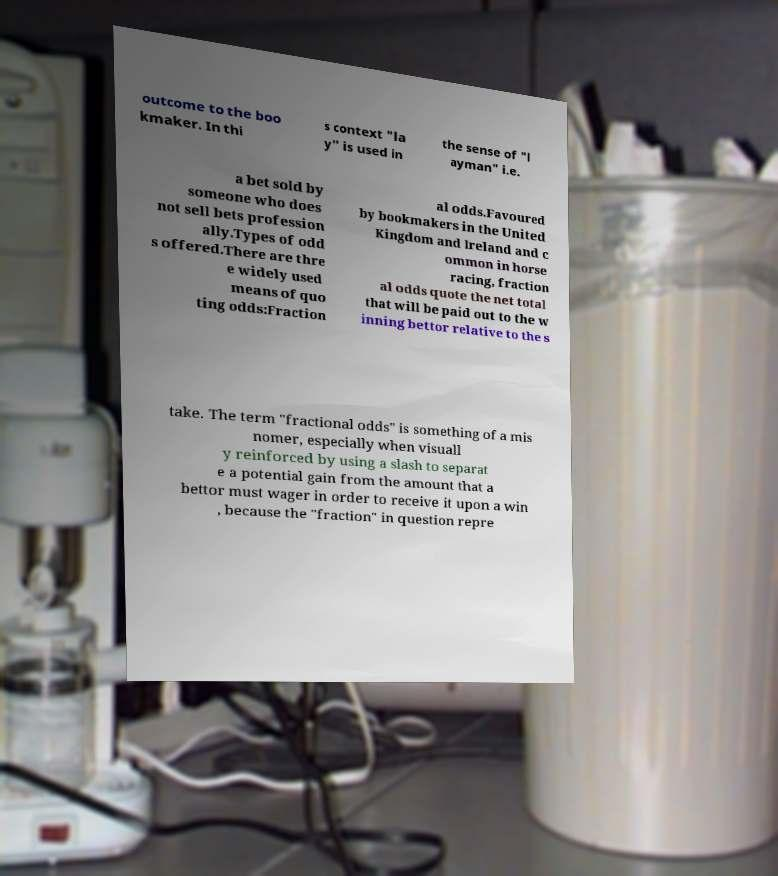What messages or text are displayed in this image? I need them in a readable, typed format. outcome to the boo kmaker. In thi s context "la y" is used in the sense of "l ayman" i.e. a bet sold by someone who does not sell bets profession ally.Types of odd s offered.There are thre e widely used means of quo ting odds:Fraction al odds.Favoured by bookmakers in the United Kingdom and Ireland and c ommon in horse racing, fraction al odds quote the net total that will be paid out to the w inning bettor relative to the s take. The term "fractional odds" is something of a mis nomer, especially when visuall y reinforced by using a slash to separat e a potential gain from the amount that a bettor must wager in order to receive it upon a win , because the "fraction" in question repre 